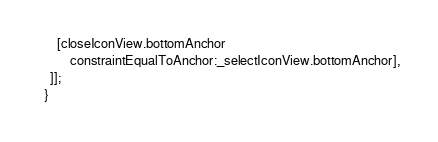Convert code to text. <code><loc_0><loc_0><loc_500><loc_500><_ObjectiveC_>      [closeIconView.bottomAnchor
          constraintEqualToAnchor:_selectIconView.bottomAnchor],
    ]];
  }
</code> 